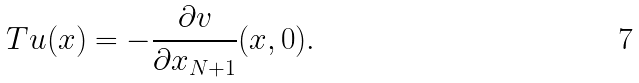<formula> <loc_0><loc_0><loc_500><loc_500>T u ( x ) = - \frac { \partial v } { \partial x _ { N + 1 } } ( x , 0 ) .</formula> 